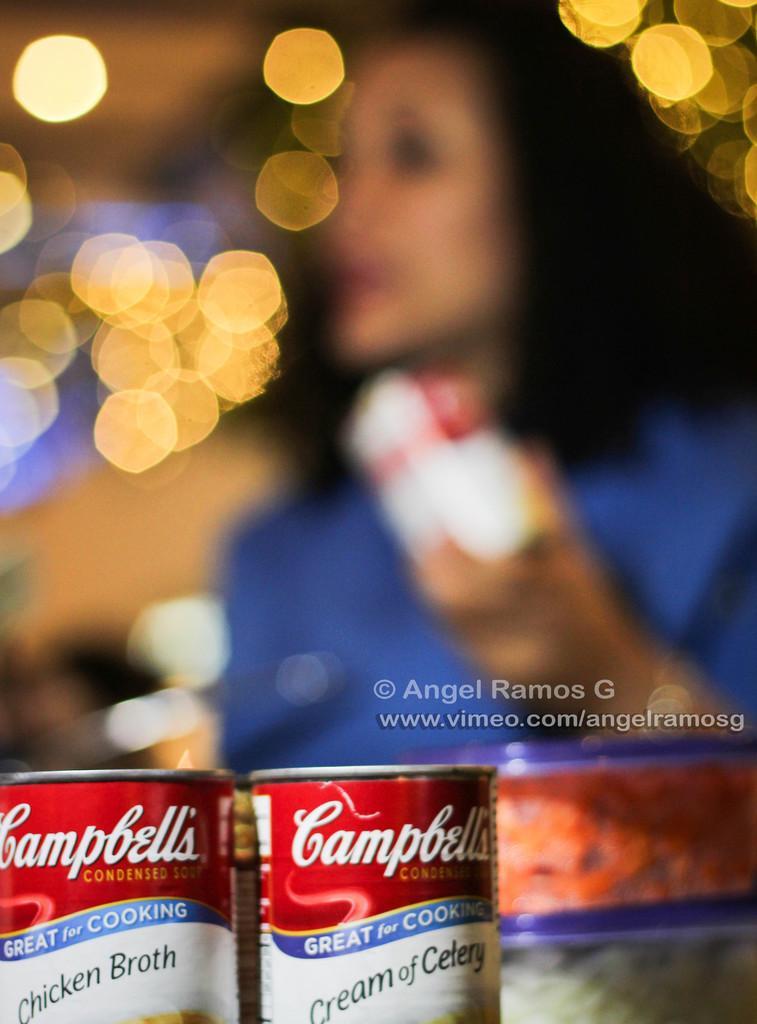Describe this image in one or two sentences. On the right side of the image a lady is holding an object in her hand. At the bottom of the image we can see bottles and some containers are there. In the background of the image lights are present. 